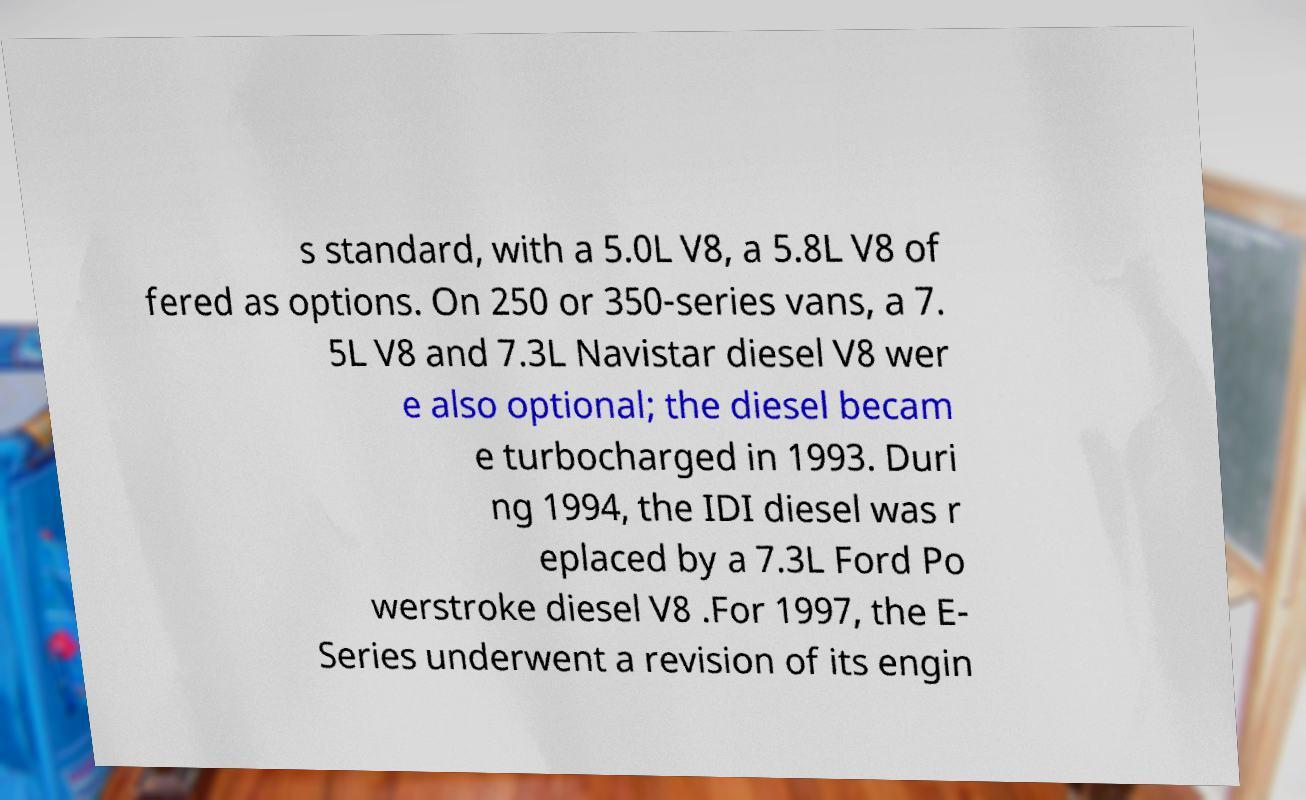Please identify and transcribe the text found in this image. s standard, with a 5.0L V8, a 5.8L V8 of fered as options. On 250 or 350-series vans, a 7. 5L V8 and 7.3L Navistar diesel V8 wer e also optional; the diesel becam e turbocharged in 1993. Duri ng 1994, the IDI diesel was r eplaced by a 7.3L Ford Po werstroke diesel V8 .For 1997, the E- Series underwent a revision of its engin 